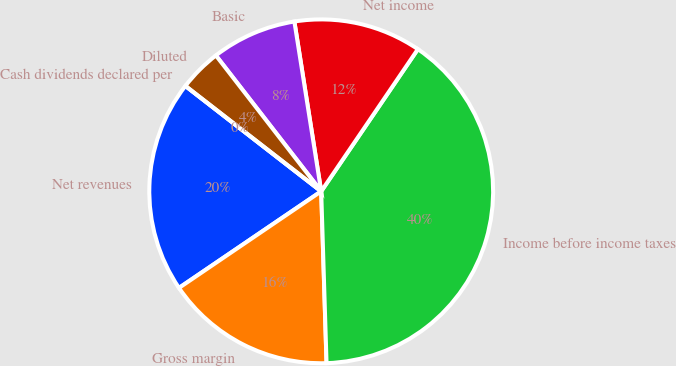<chart> <loc_0><loc_0><loc_500><loc_500><pie_chart><fcel>Net revenues<fcel>Gross margin<fcel>Income before income taxes<fcel>Net income<fcel>Basic<fcel>Diluted<fcel>Cash dividends declared per<nl><fcel>20.0%<fcel>16.0%<fcel>40.0%<fcel>12.0%<fcel>8.0%<fcel>4.0%<fcel>0.0%<nl></chart> 